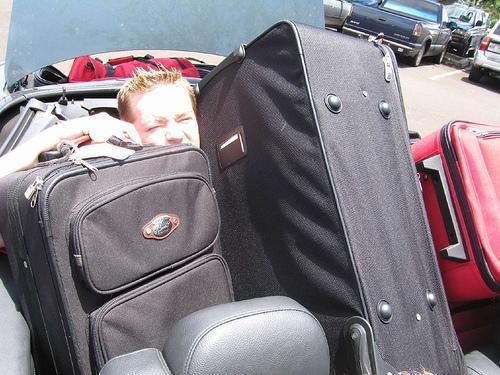How many suitcases are there?
Give a very brief answer. 3. 